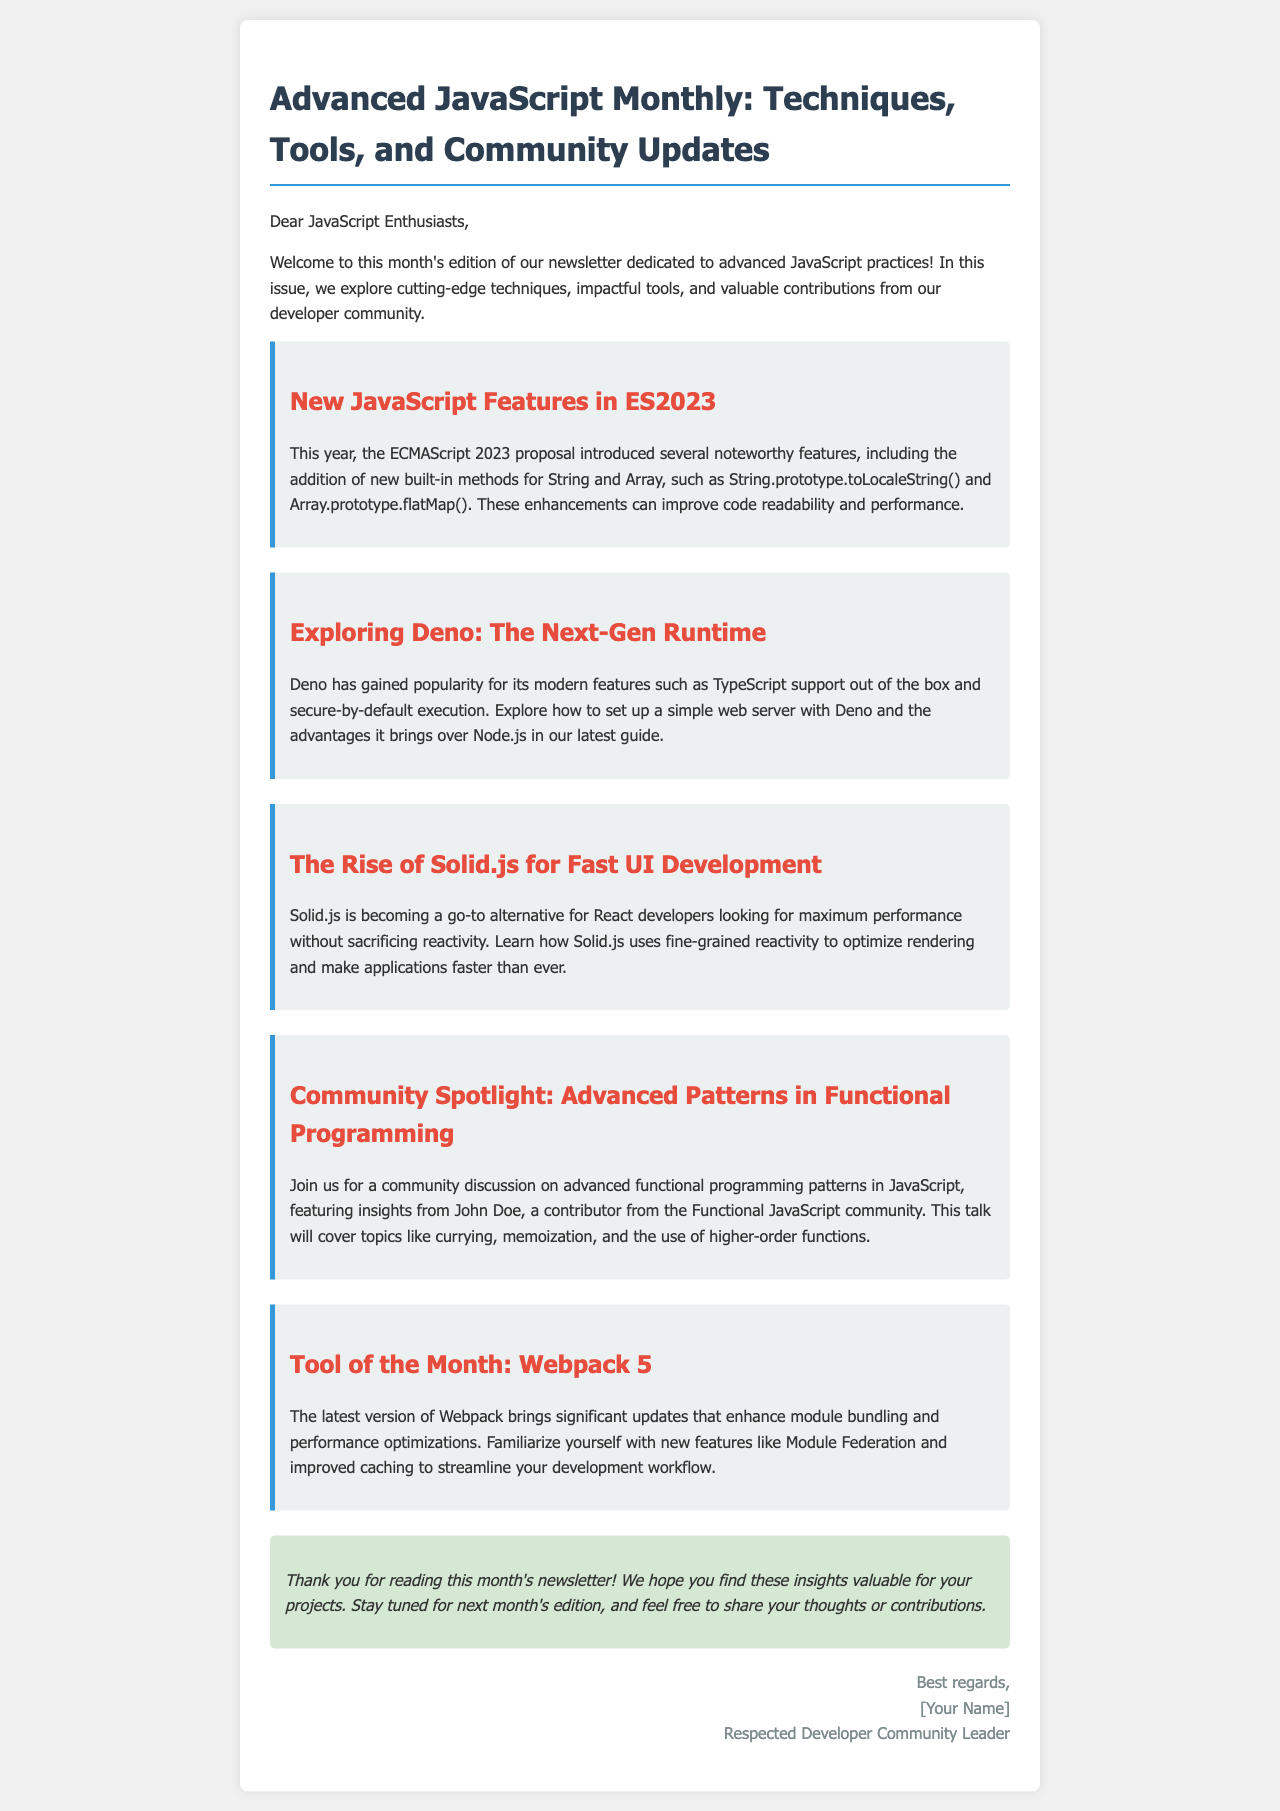What are the new built-in methods introduced in ES2023? The document mentions the addition of String.prototype.toLocaleString() and Array.prototype.flatMap() as noteworthy features from ES2023.
Answer: String.prototype.toLocaleString() and Array.prototype.flatMap() What is the topic of the community spotlight section? The community spotlight section features insights on advanced functional programming patterns in JavaScript.
Answer: Advanced patterns in functional programming Who is featured in the community discussion? The document states that John Doe, a contributor from the Functional JavaScript community, is featured in the discussion.
Answer: John Doe What is the main advantage of Deno mentioned in the newsletter? Deno is highlighted for its modern features, particularly TypeScript support out of the box and secure-by-default execution.
Answer: TypeScript support and secure-by-default execution What tool is highlighted as the tool of the month? The document identifies Webpack 5 as the tool of the month, detailing its significant updates.
Answer: Webpack 5 What color is used for the section headers in the newsletter? The document describes the color of the section headers as red (color: #e74c3c).
Answer: Red What should readers do if they want to share their thoughts or contributions? The document invites readers to feel free to share their thoughts or contributions.
Answer: Share thoughts or contributions What is the conclusion's style described in the newsletter? The document mentions that the conclusion is styled in italic and features a background color of light green.
Answer: Italic with light green background 